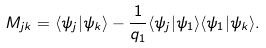<formula> <loc_0><loc_0><loc_500><loc_500>M _ { j k } = \langle \psi _ { j } | \psi _ { k } \rangle - \frac { 1 } { q _ { 1 } } \langle \psi _ { j } | \psi _ { 1 } \rangle \langle \psi _ { 1 } | \psi _ { k } \rangle .</formula> 